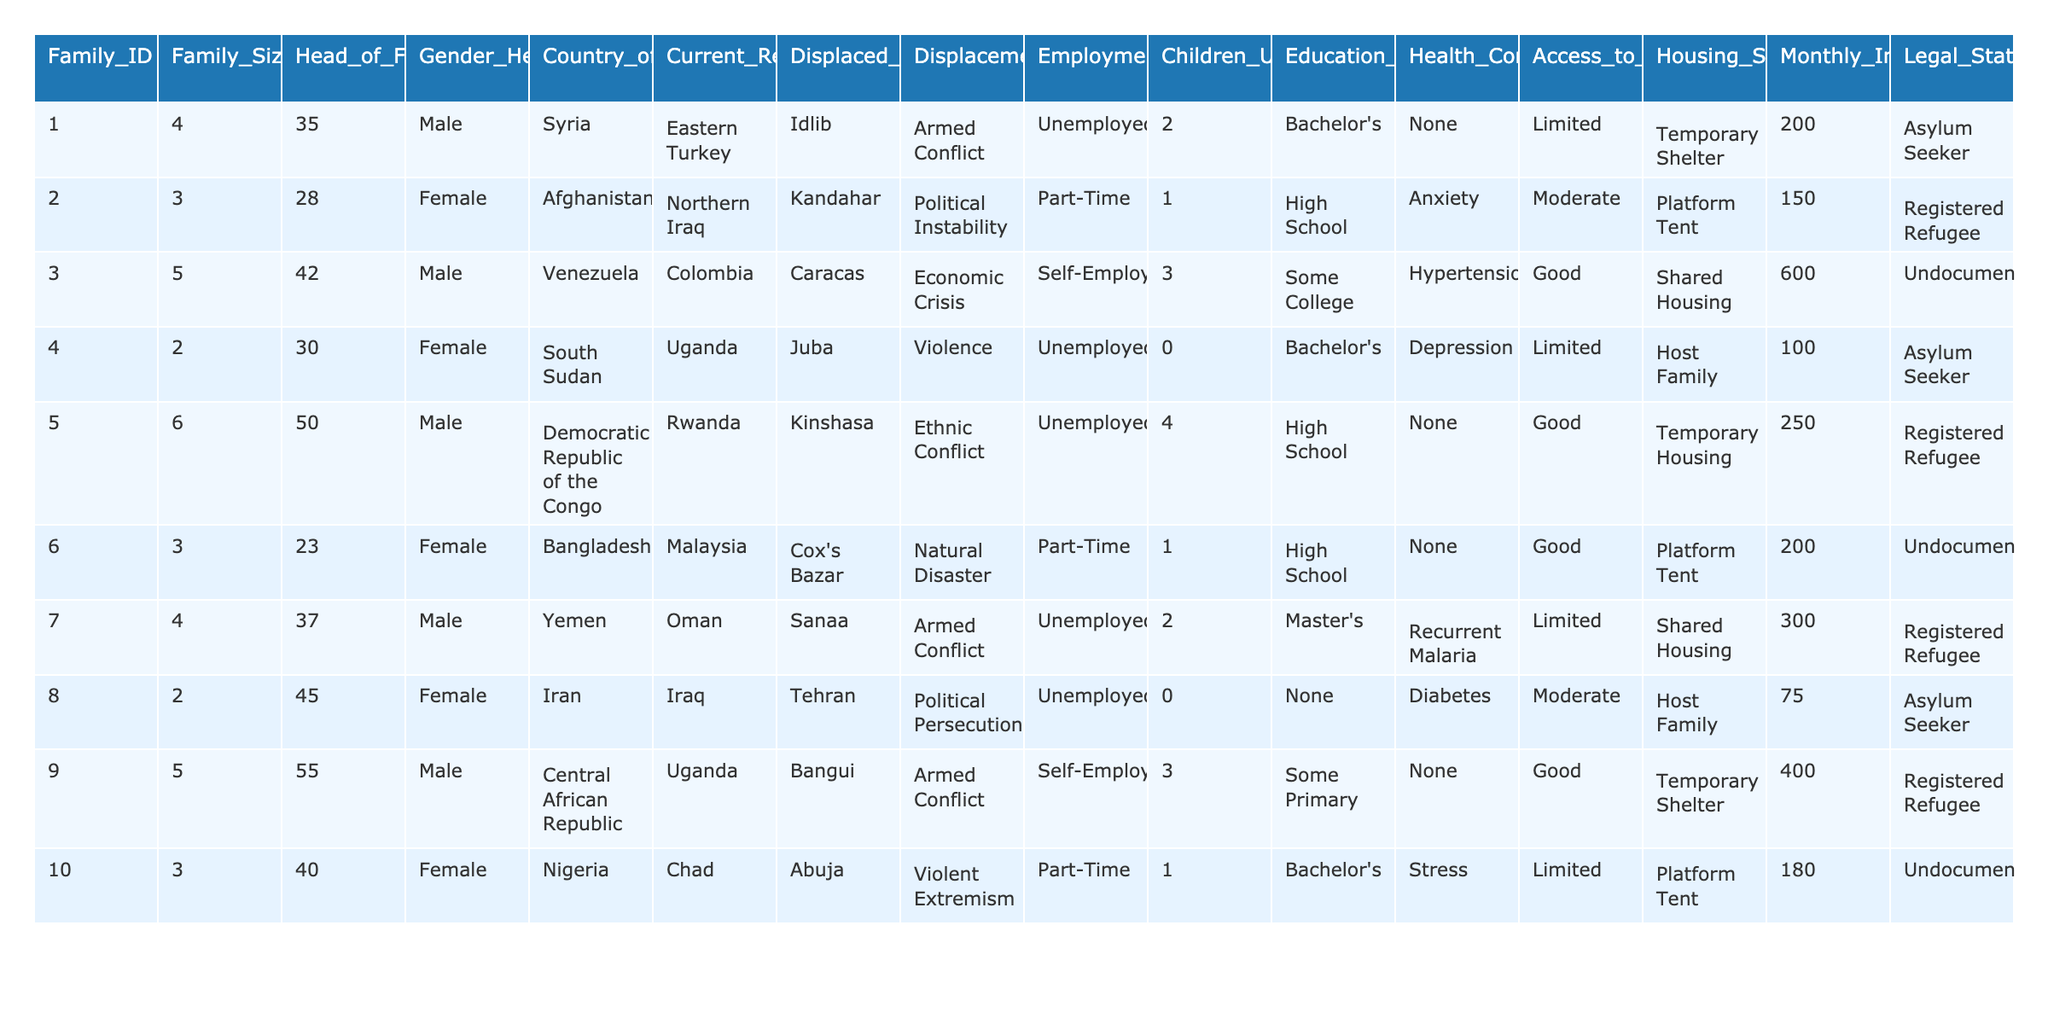What is the Family Size of Family ID 3? The Family Size for Family ID 3 is found directly in the table under the Family_Size column corresponding to the Family_ID of 3. The value is 5.
Answer: 5 How many families are currently living in Temporary Shelter? To find this, we check the Housing_Situation column and count the number of families listed as in Temporary Shelter. Families with IDs 1, 9, and 4 are recorded under Temporary Shelter, giving us a total of 3 families.
Answer: 3 What is the average Monthly Income of the families in this table? We sum the Monthly Income values: (200 + 150 + 600 + 100 + 250 + 200 + 300 + 75 + 400 + 180) = 2255. The number of families is 10, so the average Monthly Income is 2255 / 10 = 225.5.
Answer: 225.5 How many families have children under 18? We look at the Children_Under_18 column and count the families with a value greater than 0. Families with IDs 1, 2, 3, 5, 7, and 10 have children under 18. That gives us a total of 6 families.
Answer: 6 Is there a family from Central African Republic currently displaced? We check the Country_of_Origin column for "Central African Republic." Since Family ID 9 has that origin, the answer is yes.
Answer: Yes What is the percentage of families that are registered refugees? We count the families that have a Legal_Status of "Registered Refugee." Families with IDs 2, 5, 7, and 9 correspond to this status, amounting to 4 families. Out of 10 total families, the percentage is (4/10) * 100 = 40%.
Answer: 40% Which family has the Head of Family with the highest age? We examine the Head_of_Family_Age column and identify the maximum age value. The oldest head of family is Family ID 9 with an age of 55.
Answer: Family ID 9 How many families are employed in self-employment? We check the Employment_Status column for "Self-Employed." Family IDs 3 and 9 are the only families with this status. Thus, there are 2 families.
Answer: 2 What is the most common Displacement Reason among the families? We analyze the Displacement_Reason column to determine which reason appears most frequently. "Armed Conflict" appears for Families 1, 3, and 9, totaling 3 occurrences; this is the most common reason.
Answer: Armed Conflict Are there any families with documented legal status? We verify the Legal_Status column for any entries other than "Undocumented." Family IDs 2, 5, and 7 show "Registered Refugee" and Family ID 1 shows "Asylum Seeker", indicating there are families with documented status.
Answer: Yes 